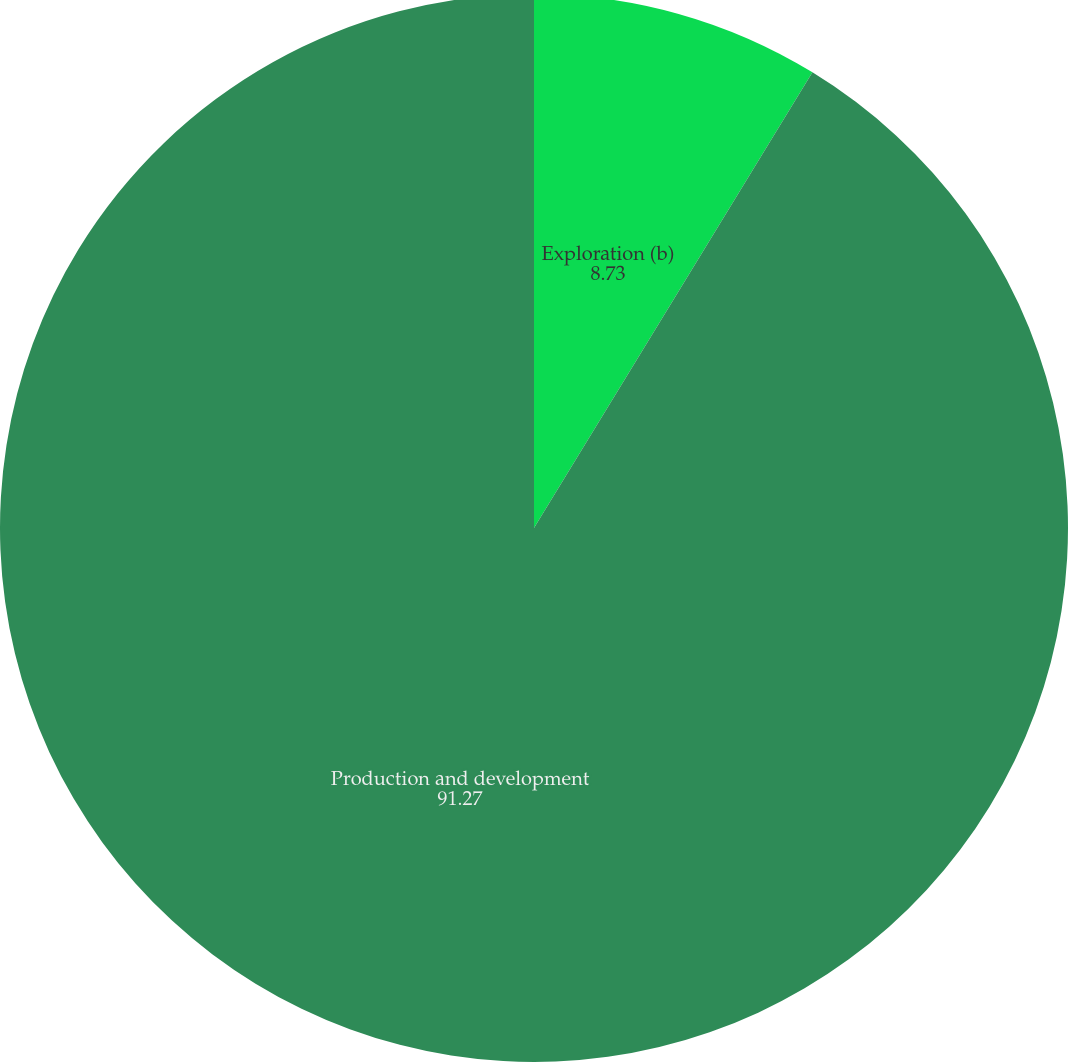Convert chart to OTSL. <chart><loc_0><loc_0><loc_500><loc_500><pie_chart><fcel>Exploration (b)<fcel>Production and development<nl><fcel>8.73%<fcel>91.27%<nl></chart> 